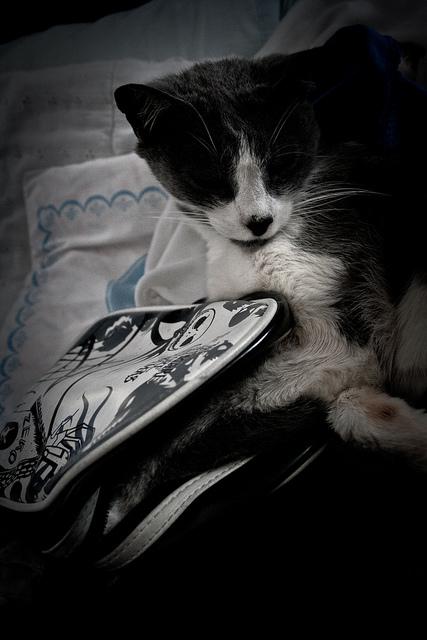Is the cat asleep?
Be succinct. No. What color is this kitty?
Give a very brief answer. Black and white. Is the cat holding a shoe?
Be succinct. No. Is the cat one color?
Concise answer only. No. Is the cat sleeping?
Short answer required. Yes. Will this cat attack?
Concise answer only. No. 